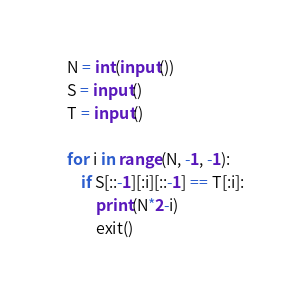<code> <loc_0><loc_0><loc_500><loc_500><_Python_>N = int(input())
S = input()
T = input()

for i in range(N, -1, -1):
    if S[::-1][:i][::-1] == T[:i]:
        print(N*2-i)
        exit()</code> 